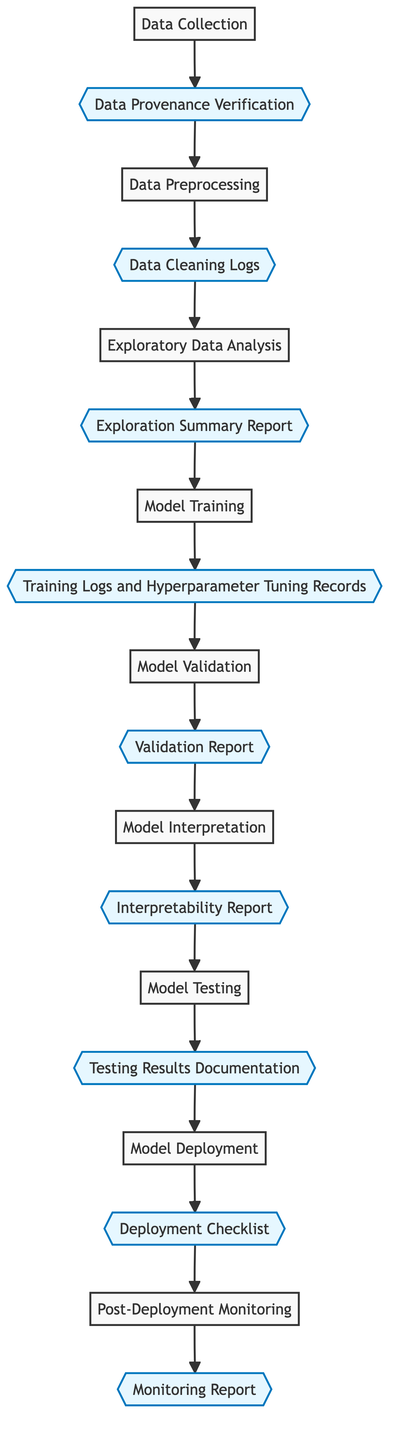What is the first step in the workflow? The diagram indicates that the first step in the workflow is "Data Collection." This is the initial action required to begin the entire process flow.
Answer: Data Collection How many accountability checkpoints are in the workflow? The diagram shows a total of nine accountability checkpoints, each associated with different steps in the workflow.
Answer: Nine What is the accountability checkpoint for "Model Training"? According to the diagram, the accountability checkpoint for "Model Training" is "Training Logs and Hyperparameter Tuning Records." This checkpoint ensures that the training process is documented and holds records of tuning.
Answer: Training Logs and Hyperparameter Tuning Records What step comes after "Exploratory Data Analysis"? By following the directed connections in the diagram, the step that comes after "Exploratory Data Analysis" is "Model Training." This shows the flow and progression from understanding data to building models.
Answer: Model Training Which step is directly linked to "Post-Deployment Monitoring"? The diagram indicates that "Post-Deployment Monitoring" is directly linked to the checkpoint labeled "Monitoring Report." This highlights the monitoring aspect of model performance post-deployment.
Answer: Monitoring Report How many steps are there in the workflow? The flowchart depicts a total of eight steps in the end-to-end workflow from data collection to model deployment, detailing each stage of the process.
Answer: Eight What are the last two steps in the workflow? The last two steps in the workflow, as per the diagram, are "Model Deployment" and "Post-Deployment Monitoring." This shows the finalization and ongoing oversight of the deployed model.
Answer: Model Deployment and Post-Deployment Monitoring Which accountability checkpoint is associated with "Model Interpretation"? The diagram links "Model Interpretation" with the accountability checkpoint titled "Interpretability Report." This emphasizes the need for transparency in how models make decisions.
Answer: Interpretability Report What is the focus of the "Data Preprocessing" step? The focus of the "Data Preprocessing" step, as described in the diagram, is to "Clean and transform the raw data into a useful format," ensuring data readiness for analysis and model building.
Answer: Clean and transform the raw data into a useful format 